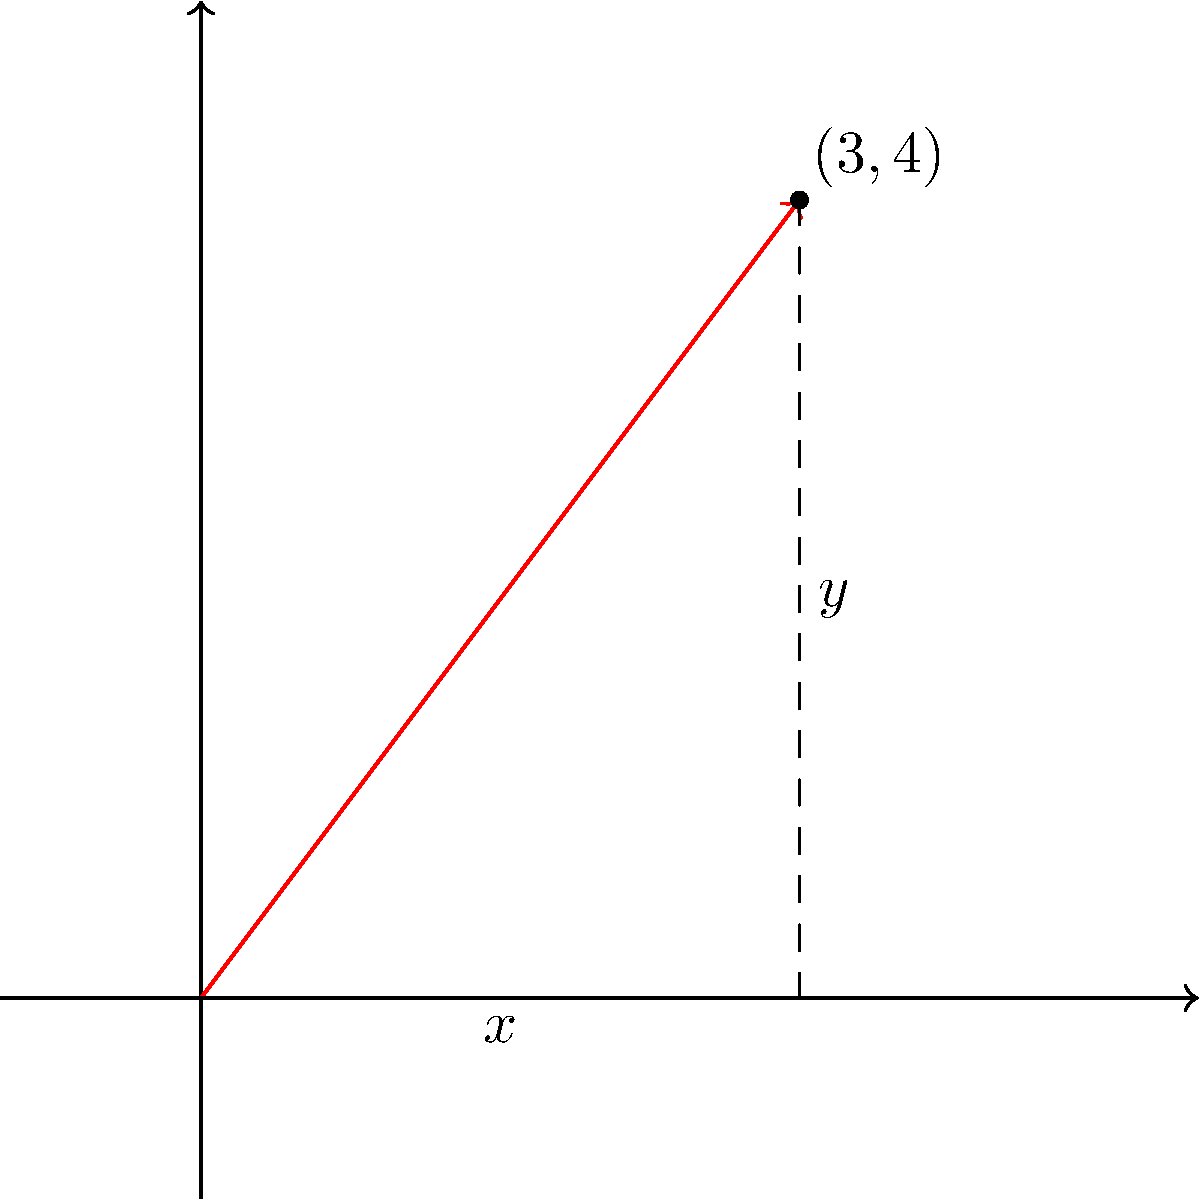In your Java library for ANT build script enhancements, you're implementing a utility class for vector calculations. Given a vector with components $x = 3$ and $y = 4$, calculate its magnitude and direction (in radians). Round your answers to two decimal places. To solve this problem, we'll follow these steps:

1. Calculate the magnitude:
   The magnitude of a vector is given by the formula:
   $$\text{magnitude} = \sqrt{x^2 + y^2}$$
   
   Substituting the values:
   $$\text{magnitude} = \sqrt{3^2 + 4^2} = \sqrt{9 + 16} = \sqrt{25} = 5$$

2. Calculate the direction:
   The direction (angle) of a vector is given by the arctangent of y/x:
   $$\text{direction} = \arctan(\frac{y}{x})$$
   
   Substituting the values:
   $$\text{direction} = \arctan(\frac{4}{3})$$
   
   Using a calculator or Java's Math.atan() function:
   $$\text{direction} \approx 0.9272952180016122 \text{ radians}$$

3. Rounding to two decimal places:
   Magnitude: 5.00
   Direction: 0.93 radians

In Java, you could implement this calculation as follows:

```java
public class VectorUtils {
    public static double[] calculateMagnitudeAndDirection(double x, double y) {
        double magnitude = Math.sqrt(x*x + y*y);
        double direction = Math.atan2(y, x);
        return new double[]{Math.round(magnitude * 100) / 100.0, Math.round(direction * 100) / 100.0};
    }
}
```

This method returns an array with the magnitude and direction, both rounded to two decimal places.
Answer: Magnitude: 5.00, Direction: 0.93 radians 